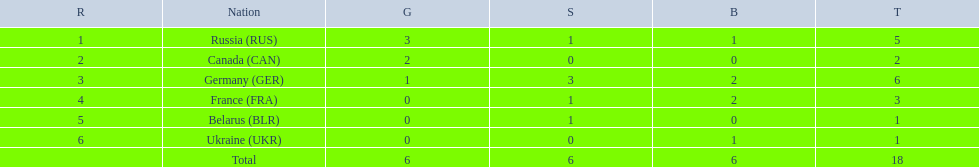What country only received gold medals in the 1994 winter olympics biathlon? Canada (CAN). 